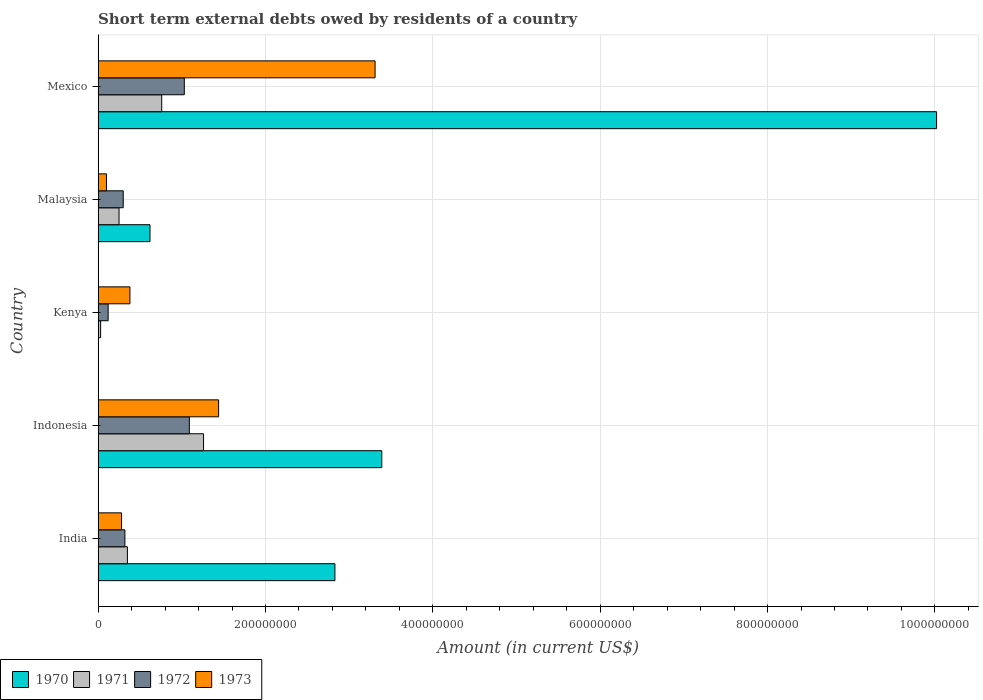How many different coloured bars are there?
Give a very brief answer. 4. How many groups of bars are there?
Ensure brevity in your answer.  5. Are the number of bars on each tick of the Y-axis equal?
Your answer should be very brief. No. In how many cases, is the number of bars for a given country not equal to the number of legend labels?
Your response must be concise. 1. What is the amount of short-term external debts owed by residents in 1973 in Indonesia?
Provide a succinct answer. 1.44e+08. Across all countries, what is the maximum amount of short-term external debts owed by residents in 1971?
Your response must be concise. 1.26e+08. Across all countries, what is the minimum amount of short-term external debts owed by residents in 1972?
Give a very brief answer. 1.20e+07. What is the total amount of short-term external debts owed by residents in 1971 in the graph?
Give a very brief answer. 2.65e+08. What is the difference between the amount of short-term external debts owed by residents in 1973 in India and that in Mexico?
Provide a short and direct response. -3.03e+08. What is the difference between the amount of short-term external debts owed by residents in 1972 in Malaysia and the amount of short-term external debts owed by residents in 1970 in Kenya?
Give a very brief answer. 3.00e+07. What is the average amount of short-term external debts owed by residents in 1973 per country?
Give a very brief answer. 1.10e+08. What is the difference between the amount of short-term external debts owed by residents in 1971 and amount of short-term external debts owed by residents in 1972 in Malaysia?
Make the answer very short. -5.00e+06. What is the ratio of the amount of short-term external debts owed by residents in 1970 in India to that in Malaysia?
Make the answer very short. 4.56. Is the difference between the amount of short-term external debts owed by residents in 1971 in Malaysia and Mexico greater than the difference between the amount of short-term external debts owed by residents in 1972 in Malaysia and Mexico?
Offer a very short reply. Yes. What is the difference between the highest and the second highest amount of short-term external debts owed by residents in 1970?
Keep it short and to the point. 6.63e+08. What is the difference between the highest and the lowest amount of short-term external debts owed by residents in 1972?
Provide a succinct answer. 9.70e+07. In how many countries, is the amount of short-term external debts owed by residents in 1973 greater than the average amount of short-term external debts owed by residents in 1973 taken over all countries?
Give a very brief answer. 2. Is it the case that in every country, the sum of the amount of short-term external debts owed by residents in 1973 and amount of short-term external debts owed by residents in 1972 is greater than the sum of amount of short-term external debts owed by residents in 1970 and amount of short-term external debts owed by residents in 1971?
Provide a succinct answer. No. How many bars are there?
Your answer should be very brief. 19. Does the graph contain any zero values?
Your answer should be very brief. Yes. What is the title of the graph?
Ensure brevity in your answer.  Short term external debts owed by residents of a country. Does "1976" appear as one of the legend labels in the graph?
Offer a very short reply. No. What is the label or title of the Y-axis?
Make the answer very short. Country. What is the Amount (in current US$) in 1970 in India?
Provide a short and direct response. 2.83e+08. What is the Amount (in current US$) of 1971 in India?
Your answer should be compact. 3.50e+07. What is the Amount (in current US$) in 1972 in India?
Your response must be concise. 3.20e+07. What is the Amount (in current US$) in 1973 in India?
Your answer should be compact. 2.80e+07. What is the Amount (in current US$) of 1970 in Indonesia?
Offer a terse response. 3.39e+08. What is the Amount (in current US$) of 1971 in Indonesia?
Keep it short and to the point. 1.26e+08. What is the Amount (in current US$) of 1972 in Indonesia?
Give a very brief answer. 1.09e+08. What is the Amount (in current US$) of 1973 in Indonesia?
Keep it short and to the point. 1.44e+08. What is the Amount (in current US$) in 1970 in Kenya?
Provide a succinct answer. 0. What is the Amount (in current US$) in 1971 in Kenya?
Offer a terse response. 3.00e+06. What is the Amount (in current US$) in 1972 in Kenya?
Ensure brevity in your answer.  1.20e+07. What is the Amount (in current US$) in 1973 in Kenya?
Give a very brief answer. 3.80e+07. What is the Amount (in current US$) in 1970 in Malaysia?
Make the answer very short. 6.20e+07. What is the Amount (in current US$) in 1971 in Malaysia?
Make the answer very short. 2.50e+07. What is the Amount (in current US$) of 1972 in Malaysia?
Keep it short and to the point. 3.00e+07. What is the Amount (in current US$) of 1970 in Mexico?
Keep it short and to the point. 1.00e+09. What is the Amount (in current US$) in 1971 in Mexico?
Your response must be concise. 7.60e+07. What is the Amount (in current US$) in 1972 in Mexico?
Your answer should be compact. 1.03e+08. What is the Amount (in current US$) of 1973 in Mexico?
Give a very brief answer. 3.31e+08. Across all countries, what is the maximum Amount (in current US$) in 1970?
Make the answer very short. 1.00e+09. Across all countries, what is the maximum Amount (in current US$) of 1971?
Keep it short and to the point. 1.26e+08. Across all countries, what is the maximum Amount (in current US$) in 1972?
Offer a terse response. 1.09e+08. Across all countries, what is the maximum Amount (in current US$) of 1973?
Your answer should be compact. 3.31e+08. Across all countries, what is the minimum Amount (in current US$) in 1970?
Make the answer very short. 0. Across all countries, what is the minimum Amount (in current US$) in 1972?
Your answer should be very brief. 1.20e+07. Across all countries, what is the minimum Amount (in current US$) in 1973?
Give a very brief answer. 1.00e+07. What is the total Amount (in current US$) of 1970 in the graph?
Your answer should be very brief. 1.69e+09. What is the total Amount (in current US$) of 1971 in the graph?
Keep it short and to the point. 2.65e+08. What is the total Amount (in current US$) of 1972 in the graph?
Ensure brevity in your answer.  2.86e+08. What is the total Amount (in current US$) in 1973 in the graph?
Your response must be concise. 5.51e+08. What is the difference between the Amount (in current US$) in 1970 in India and that in Indonesia?
Give a very brief answer. -5.60e+07. What is the difference between the Amount (in current US$) in 1971 in India and that in Indonesia?
Your response must be concise. -9.10e+07. What is the difference between the Amount (in current US$) of 1972 in India and that in Indonesia?
Offer a terse response. -7.70e+07. What is the difference between the Amount (in current US$) in 1973 in India and that in Indonesia?
Your response must be concise. -1.16e+08. What is the difference between the Amount (in current US$) in 1971 in India and that in Kenya?
Provide a succinct answer. 3.20e+07. What is the difference between the Amount (in current US$) of 1973 in India and that in Kenya?
Offer a very short reply. -1.00e+07. What is the difference between the Amount (in current US$) in 1970 in India and that in Malaysia?
Offer a terse response. 2.21e+08. What is the difference between the Amount (in current US$) of 1972 in India and that in Malaysia?
Provide a short and direct response. 2.00e+06. What is the difference between the Amount (in current US$) of 1973 in India and that in Malaysia?
Offer a very short reply. 1.80e+07. What is the difference between the Amount (in current US$) of 1970 in India and that in Mexico?
Offer a very short reply. -7.19e+08. What is the difference between the Amount (in current US$) in 1971 in India and that in Mexico?
Your answer should be very brief. -4.10e+07. What is the difference between the Amount (in current US$) of 1972 in India and that in Mexico?
Keep it short and to the point. -7.10e+07. What is the difference between the Amount (in current US$) in 1973 in India and that in Mexico?
Keep it short and to the point. -3.03e+08. What is the difference between the Amount (in current US$) of 1971 in Indonesia and that in Kenya?
Provide a short and direct response. 1.23e+08. What is the difference between the Amount (in current US$) of 1972 in Indonesia and that in Kenya?
Offer a terse response. 9.70e+07. What is the difference between the Amount (in current US$) of 1973 in Indonesia and that in Kenya?
Offer a terse response. 1.06e+08. What is the difference between the Amount (in current US$) in 1970 in Indonesia and that in Malaysia?
Provide a succinct answer. 2.77e+08. What is the difference between the Amount (in current US$) in 1971 in Indonesia and that in Malaysia?
Your response must be concise. 1.01e+08. What is the difference between the Amount (in current US$) of 1972 in Indonesia and that in Malaysia?
Keep it short and to the point. 7.90e+07. What is the difference between the Amount (in current US$) in 1973 in Indonesia and that in Malaysia?
Make the answer very short. 1.34e+08. What is the difference between the Amount (in current US$) in 1970 in Indonesia and that in Mexico?
Offer a very short reply. -6.63e+08. What is the difference between the Amount (in current US$) of 1973 in Indonesia and that in Mexico?
Make the answer very short. -1.87e+08. What is the difference between the Amount (in current US$) in 1971 in Kenya and that in Malaysia?
Offer a terse response. -2.20e+07. What is the difference between the Amount (in current US$) in 1972 in Kenya and that in Malaysia?
Keep it short and to the point. -1.80e+07. What is the difference between the Amount (in current US$) in 1973 in Kenya and that in Malaysia?
Your answer should be very brief. 2.80e+07. What is the difference between the Amount (in current US$) of 1971 in Kenya and that in Mexico?
Your response must be concise. -7.30e+07. What is the difference between the Amount (in current US$) of 1972 in Kenya and that in Mexico?
Offer a very short reply. -9.10e+07. What is the difference between the Amount (in current US$) of 1973 in Kenya and that in Mexico?
Ensure brevity in your answer.  -2.93e+08. What is the difference between the Amount (in current US$) of 1970 in Malaysia and that in Mexico?
Give a very brief answer. -9.40e+08. What is the difference between the Amount (in current US$) of 1971 in Malaysia and that in Mexico?
Make the answer very short. -5.10e+07. What is the difference between the Amount (in current US$) of 1972 in Malaysia and that in Mexico?
Your answer should be very brief. -7.30e+07. What is the difference between the Amount (in current US$) in 1973 in Malaysia and that in Mexico?
Provide a short and direct response. -3.21e+08. What is the difference between the Amount (in current US$) in 1970 in India and the Amount (in current US$) in 1971 in Indonesia?
Keep it short and to the point. 1.57e+08. What is the difference between the Amount (in current US$) in 1970 in India and the Amount (in current US$) in 1972 in Indonesia?
Your answer should be compact. 1.74e+08. What is the difference between the Amount (in current US$) of 1970 in India and the Amount (in current US$) of 1973 in Indonesia?
Offer a terse response. 1.39e+08. What is the difference between the Amount (in current US$) in 1971 in India and the Amount (in current US$) in 1972 in Indonesia?
Provide a succinct answer. -7.40e+07. What is the difference between the Amount (in current US$) in 1971 in India and the Amount (in current US$) in 1973 in Indonesia?
Give a very brief answer. -1.09e+08. What is the difference between the Amount (in current US$) in 1972 in India and the Amount (in current US$) in 1973 in Indonesia?
Your response must be concise. -1.12e+08. What is the difference between the Amount (in current US$) in 1970 in India and the Amount (in current US$) in 1971 in Kenya?
Offer a very short reply. 2.80e+08. What is the difference between the Amount (in current US$) of 1970 in India and the Amount (in current US$) of 1972 in Kenya?
Keep it short and to the point. 2.71e+08. What is the difference between the Amount (in current US$) of 1970 in India and the Amount (in current US$) of 1973 in Kenya?
Ensure brevity in your answer.  2.45e+08. What is the difference between the Amount (in current US$) of 1971 in India and the Amount (in current US$) of 1972 in Kenya?
Give a very brief answer. 2.30e+07. What is the difference between the Amount (in current US$) of 1972 in India and the Amount (in current US$) of 1973 in Kenya?
Your answer should be compact. -6.00e+06. What is the difference between the Amount (in current US$) in 1970 in India and the Amount (in current US$) in 1971 in Malaysia?
Give a very brief answer. 2.58e+08. What is the difference between the Amount (in current US$) of 1970 in India and the Amount (in current US$) of 1972 in Malaysia?
Keep it short and to the point. 2.53e+08. What is the difference between the Amount (in current US$) of 1970 in India and the Amount (in current US$) of 1973 in Malaysia?
Provide a succinct answer. 2.73e+08. What is the difference between the Amount (in current US$) in 1971 in India and the Amount (in current US$) in 1972 in Malaysia?
Offer a terse response. 5.00e+06. What is the difference between the Amount (in current US$) of 1971 in India and the Amount (in current US$) of 1973 in Malaysia?
Keep it short and to the point. 2.50e+07. What is the difference between the Amount (in current US$) of 1972 in India and the Amount (in current US$) of 1973 in Malaysia?
Offer a very short reply. 2.20e+07. What is the difference between the Amount (in current US$) in 1970 in India and the Amount (in current US$) in 1971 in Mexico?
Offer a terse response. 2.07e+08. What is the difference between the Amount (in current US$) of 1970 in India and the Amount (in current US$) of 1972 in Mexico?
Your response must be concise. 1.80e+08. What is the difference between the Amount (in current US$) in 1970 in India and the Amount (in current US$) in 1973 in Mexico?
Offer a very short reply. -4.80e+07. What is the difference between the Amount (in current US$) of 1971 in India and the Amount (in current US$) of 1972 in Mexico?
Provide a short and direct response. -6.80e+07. What is the difference between the Amount (in current US$) of 1971 in India and the Amount (in current US$) of 1973 in Mexico?
Your answer should be very brief. -2.96e+08. What is the difference between the Amount (in current US$) of 1972 in India and the Amount (in current US$) of 1973 in Mexico?
Offer a terse response. -2.99e+08. What is the difference between the Amount (in current US$) in 1970 in Indonesia and the Amount (in current US$) in 1971 in Kenya?
Give a very brief answer. 3.36e+08. What is the difference between the Amount (in current US$) in 1970 in Indonesia and the Amount (in current US$) in 1972 in Kenya?
Offer a very short reply. 3.27e+08. What is the difference between the Amount (in current US$) in 1970 in Indonesia and the Amount (in current US$) in 1973 in Kenya?
Ensure brevity in your answer.  3.01e+08. What is the difference between the Amount (in current US$) in 1971 in Indonesia and the Amount (in current US$) in 1972 in Kenya?
Make the answer very short. 1.14e+08. What is the difference between the Amount (in current US$) of 1971 in Indonesia and the Amount (in current US$) of 1973 in Kenya?
Offer a terse response. 8.80e+07. What is the difference between the Amount (in current US$) in 1972 in Indonesia and the Amount (in current US$) in 1973 in Kenya?
Your answer should be compact. 7.10e+07. What is the difference between the Amount (in current US$) of 1970 in Indonesia and the Amount (in current US$) of 1971 in Malaysia?
Give a very brief answer. 3.14e+08. What is the difference between the Amount (in current US$) of 1970 in Indonesia and the Amount (in current US$) of 1972 in Malaysia?
Give a very brief answer. 3.09e+08. What is the difference between the Amount (in current US$) of 1970 in Indonesia and the Amount (in current US$) of 1973 in Malaysia?
Provide a short and direct response. 3.29e+08. What is the difference between the Amount (in current US$) in 1971 in Indonesia and the Amount (in current US$) in 1972 in Malaysia?
Provide a succinct answer. 9.60e+07. What is the difference between the Amount (in current US$) of 1971 in Indonesia and the Amount (in current US$) of 1973 in Malaysia?
Ensure brevity in your answer.  1.16e+08. What is the difference between the Amount (in current US$) of 1972 in Indonesia and the Amount (in current US$) of 1973 in Malaysia?
Your answer should be compact. 9.90e+07. What is the difference between the Amount (in current US$) in 1970 in Indonesia and the Amount (in current US$) in 1971 in Mexico?
Your answer should be compact. 2.63e+08. What is the difference between the Amount (in current US$) in 1970 in Indonesia and the Amount (in current US$) in 1972 in Mexico?
Ensure brevity in your answer.  2.36e+08. What is the difference between the Amount (in current US$) in 1970 in Indonesia and the Amount (in current US$) in 1973 in Mexico?
Give a very brief answer. 8.00e+06. What is the difference between the Amount (in current US$) of 1971 in Indonesia and the Amount (in current US$) of 1972 in Mexico?
Make the answer very short. 2.30e+07. What is the difference between the Amount (in current US$) in 1971 in Indonesia and the Amount (in current US$) in 1973 in Mexico?
Make the answer very short. -2.05e+08. What is the difference between the Amount (in current US$) of 1972 in Indonesia and the Amount (in current US$) of 1973 in Mexico?
Offer a very short reply. -2.22e+08. What is the difference between the Amount (in current US$) in 1971 in Kenya and the Amount (in current US$) in 1972 in Malaysia?
Provide a short and direct response. -2.70e+07. What is the difference between the Amount (in current US$) in 1971 in Kenya and the Amount (in current US$) in 1973 in Malaysia?
Your answer should be very brief. -7.00e+06. What is the difference between the Amount (in current US$) in 1972 in Kenya and the Amount (in current US$) in 1973 in Malaysia?
Ensure brevity in your answer.  2.00e+06. What is the difference between the Amount (in current US$) of 1971 in Kenya and the Amount (in current US$) of 1972 in Mexico?
Your answer should be very brief. -1.00e+08. What is the difference between the Amount (in current US$) in 1971 in Kenya and the Amount (in current US$) in 1973 in Mexico?
Your answer should be compact. -3.28e+08. What is the difference between the Amount (in current US$) in 1972 in Kenya and the Amount (in current US$) in 1973 in Mexico?
Offer a very short reply. -3.19e+08. What is the difference between the Amount (in current US$) of 1970 in Malaysia and the Amount (in current US$) of 1971 in Mexico?
Give a very brief answer. -1.40e+07. What is the difference between the Amount (in current US$) of 1970 in Malaysia and the Amount (in current US$) of 1972 in Mexico?
Offer a terse response. -4.10e+07. What is the difference between the Amount (in current US$) in 1970 in Malaysia and the Amount (in current US$) in 1973 in Mexico?
Provide a short and direct response. -2.69e+08. What is the difference between the Amount (in current US$) in 1971 in Malaysia and the Amount (in current US$) in 1972 in Mexico?
Provide a succinct answer. -7.80e+07. What is the difference between the Amount (in current US$) in 1971 in Malaysia and the Amount (in current US$) in 1973 in Mexico?
Make the answer very short. -3.06e+08. What is the difference between the Amount (in current US$) of 1972 in Malaysia and the Amount (in current US$) of 1973 in Mexico?
Make the answer very short. -3.01e+08. What is the average Amount (in current US$) in 1970 per country?
Offer a very short reply. 3.37e+08. What is the average Amount (in current US$) of 1971 per country?
Provide a short and direct response. 5.30e+07. What is the average Amount (in current US$) in 1972 per country?
Offer a very short reply. 5.72e+07. What is the average Amount (in current US$) in 1973 per country?
Ensure brevity in your answer.  1.10e+08. What is the difference between the Amount (in current US$) in 1970 and Amount (in current US$) in 1971 in India?
Offer a very short reply. 2.48e+08. What is the difference between the Amount (in current US$) in 1970 and Amount (in current US$) in 1972 in India?
Offer a terse response. 2.51e+08. What is the difference between the Amount (in current US$) of 1970 and Amount (in current US$) of 1973 in India?
Ensure brevity in your answer.  2.55e+08. What is the difference between the Amount (in current US$) of 1971 and Amount (in current US$) of 1972 in India?
Give a very brief answer. 3.00e+06. What is the difference between the Amount (in current US$) in 1971 and Amount (in current US$) in 1973 in India?
Your answer should be compact. 7.00e+06. What is the difference between the Amount (in current US$) in 1972 and Amount (in current US$) in 1973 in India?
Your answer should be compact. 4.00e+06. What is the difference between the Amount (in current US$) in 1970 and Amount (in current US$) in 1971 in Indonesia?
Your response must be concise. 2.13e+08. What is the difference between the Amount (in current US$) of 1970 and Amount (in current US$) of 1972 in Indonesia?
Keep it short and to the point. 2.30e+08. What is the difference between the Amount (in current US$) in 1970 and Amount (in current US$) in 1973 in Indonesia?
Provide a succinct answer. 1.95e+08. What is the difference between the Amount (in current US$) in 1971 and Amount (in current US$) in 1972 in Indonesia?
Offer a very short reply. 1.70e+07. What is the difference between the Amount (in current US$) in 1971 and Amount (in current US$) in 1973 in Indonesia?
Provide a short and direct response. -1.80e+07. What is the difference between the Amount (in current US$) in 1972 and Amount (in current US$) in 1973 in Indonesia?
Make the answer very short. -3.50e+07. What is the difference between the Amount (in current US$) in 1971 and Amount (in current US$) in 1972 in Kenya?
Your answer should be very brief. -9.00e+06. What is the difference between the Amount (in current US$) in 1971 and Amount (in current US$) in 1973 in Kenya?
Provide a succinct answer. -3.50e+07. What is the difference between the Amount (in current US$) in 1972 and Amount (in current US$) in 1973 in Kenya?
Offer a terse response. -2.60e+07. What is the difference between the Amount (in current US$) of 1970 and Amount (in current US$) of 1971 in Malaysia?
Provide a short and direct response. 3.70e+07. What is the difference between the Amount (in current US$) of 1970 and Amount (in current US$) of 1972 in Malaysia?
Offer a terse response. 3.20e+07. What is the difference between the Amount (in current US$) of 1970 and Amount (in current US$) of 1973 in Malaysia?
Your response must be concise. 5.20e+07. What is the difference between the Amount (in current US$) of 1971 and Amount (in current US$) of 1972 in Malaysia?
Provide a succinct answer. -5.00e+06. What is the difference between the Amount (in current US$) in 1971 and Amount (in current US$) in 1973 in Malaysia?
Offer a very short reply. 1.50e+07. What is the difference between the Amount (in current US$) in 1970 and Amount (in current US$) in 1971 in Mexico?
Ensure brevity in your answer.  9.26e+08. What is the difference between the Amount (in current US$) of 1970 and Amount (in current US$) of 1972 in Mexico?
Provide a succinct answer. 8.99e+08. What is the difference between the Amount (in current US$) of 1970 and Amount (in current US$) of 1973 in Mexico?
Your answer should be compact. 6.71e+08. What is the difference between the Amount (in current US$) of 1971 and Amount (in current US$) of 1972 in Mexico?
Offer a very short reply. -2.70e+07. What is the difference between the Amount (in current US$) of 1971 and Amount (in current US$) of 1973 in Mexico?
Ensure brevity in your answer.  -2.55e+08. What is the difference between the Amount (in current US$) of 1972 and Amount (in current US$) of 1973 in Mexico?
Give a very brief answer. -2.28e+08. What is the ratio of the Amount (in current US$) in 1970 in India to that in Indonesia?
Your answer should be compact. 0.83. What is the ratio of the Amount (in current US$) in 1971 in India to that in Indonesia?
Ensure brevity in your answer.  0.28. What is the ratio of the Amount (in current US$) of 1972 in India to that in Indonesia?
Your answer should be compact. 0.29. What is the ratio of the Amount (in current US$) of 1973 in India to that in Indonesia?
Your answer should be very brief. 0.19. What is the ratio of the Amount (in current US$) of 1971 in India to that in Kenya?
Offer a very short reply. 11.67. What is the ratio of the Amount (in current US$) of 1972 in India to that in Kenya?
Offer a very short reply. 2.67. What is the ratio of the Amount (in current US$) of 1973 in India to that in Kenya?
Give a very brief answer. 0.74. What is the ratio of the Amount (in current US$) in 1970 in India to that in Malaysia?
Give a very brief answer. 4.56. What is the ratio of the Amount (in current US$) in 1972 in India to that in Malaysia?
Keep it short and to the point. 1.07. What is the ratio of the Amount (in current US$) of 1973 in India to that in Malaysia?
Make the answer very short. 2.8. What is the ratio of the Amount (in current US$) of 1970 in India to that in Mexico?
Keep it short and to the point. 0.28. What is the ratio of the Amount (in current US$) in 1971 in India to that in Mexico?
Your answer should be compact. 0.46. What is the ratio of the Amount (in current US$) in 1972 in India to that in Mexico?
Provide a succinct answer. 0.31. What is the ratio of the Amount (in current US$) of 1973 in India to that in Mexico?
Provide a succinct answer. 0.08. What is the ratio of the Amount (in current US$) in 1972 in Indonesia to that in Kenya?
Give a very brief answer. 9.08. What is the ratio of the Amount (in current US$) of 1973 in Indonesia to that in Kenya?
Give a very brief answer. 3.79. What is the ratio of the Amount (in current US$) in 1970 in Indonesia to that in Malaysia?
Provide a short and direct response. 5.47. What is the ratio of the Amount (in current US$) in 1971 in Indonesia to that in Malaysia?
Your answer should be compact. 5.04. What is the ratio of the Amount (in current US$) of 1972 in Indonesia to that in Malaysia?
Your answer should be very brief. 3.63. What is the ratio of the Amount (in current US$) in 1970 in Indonesia to that in Mexico?
Keep it short and to the point. 0.34. What is the ratio of the Amount (in current US$) in 1971 in Indonesia to that in Mexico?
Ensure brevity in your answer.  1.66. What is the ratio of the Amount (in current US$) of 1972 in Indonesia to that in Mexico?
Your answer should be very brief. 1.06. What is the ratio of the Amount (in current US$) in 1973 in Indonesia to that in Mexico?
Provide a succinct answer. 0.43. What is the ratio of the Amount (in current US$) of 1971 in Kenya to that in Malaysia?
Ensure brevity in your answer.  0.12. What is the ratio of the Amount (in current US$) of 1972 in Kenya to that in Malaysia?
Make the answer very short. 0.4. What is the ratio of the Amount (in current US$) of 1973 in Kenya to that in Malaysia?
Your answer should be compact. 3.8. What is the ratio of the Amount (in current US$) in 1971 in Kenya to that in Mexico?
Offer a terse response. 0.04. What is the ratio of the Amount (in current US$) in 1972 in Kenya to that in Mexico?
Your answer should be very brief. 0.12. What is the ratio of the Amount (in current US$) of 1973 in Kenya to that in Mexico?
Offer a very short reply. 0.11. What is the ratio of the Amount (in current US$) in 1970 in Malaysia to that in Mexico?
Your response must be concise. 0.06. What is the ratio of the Amount (in current US$) of 1971 in Malaysia to that in Mexico?
Give a very brief answer. 0.33. What is the ratio of the Amount (in current US$) in 1972 in Malaysia to that in Mexico?
Your answer should be very brief. 0.29. What is the ratio of the Amount (in current US$) in 1973 in Malaysia to that in Mexico?
Your response must be concise. 0.03. What is the difference between the highest and the second highest Amount (in current US$) of 1970?
Offer a terse response. 6.63e+08. What is the difference between the highest and the second highest Amount (in current US$) in 1971?
Your response must be concise. 5.00e+07. What is the difference between the highest and the second highest Amount (in current US$) in 1972?
Provide a succinct answer. 6.00e+06. What is the difference between the highest and the second highest Amount (in current US$) in 1973?
Provide a short and direct response. 1.87e+08. What is the difference between the highest and the lowest Amount (in current US$) in 1970?
Make the answer very short. 1.00e+09. What is the difference between the highest and the lowest Amount (in current US$) of 1971?
Provide a succinct answer. 1.23e+08. What is the difference between the highest and the lowest Amount (in current US$) in 1972?
Ensure brevity in your answer.  9.70e+07. What is the difference between the highest and the lowest Amount (in current US$) in 1973?
Offer a terse response. 3.21e+08. 